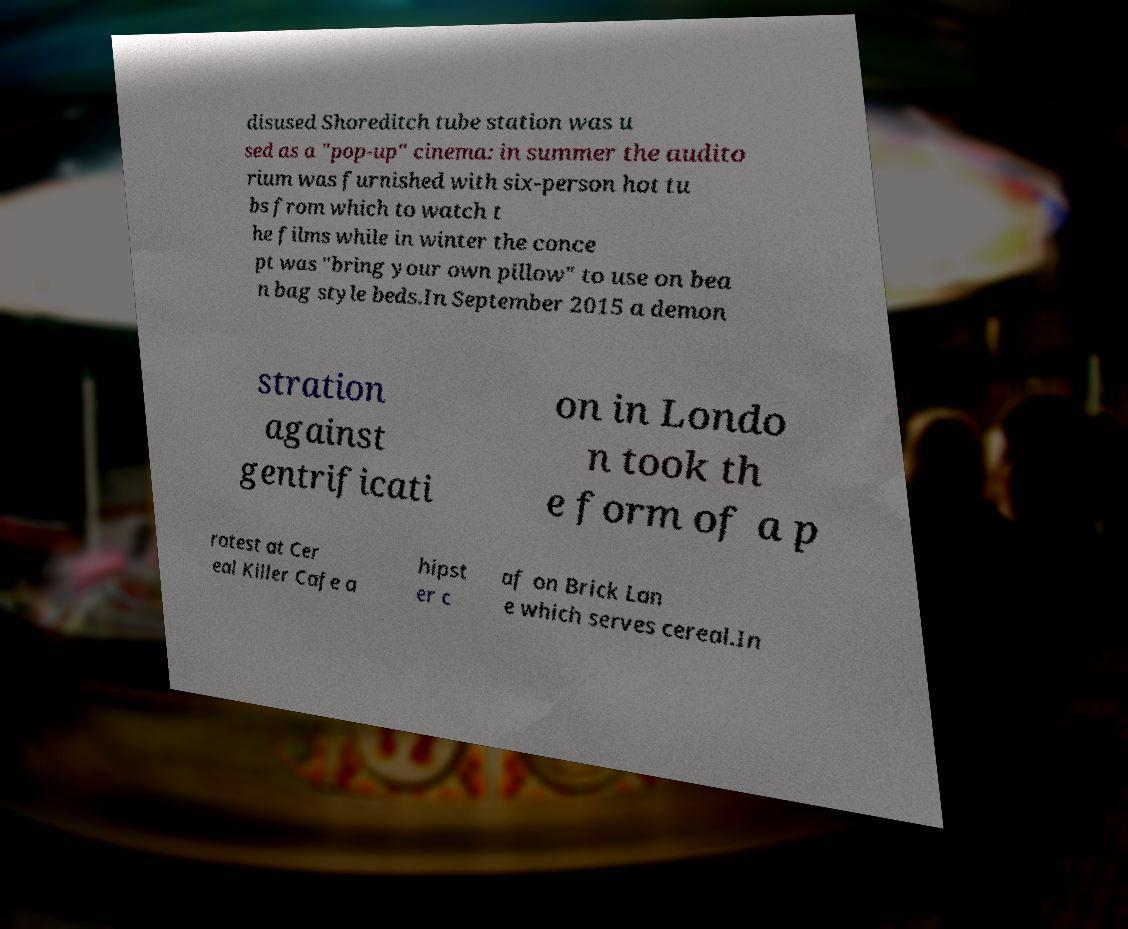Please identify and transcribe the text found in this image. disused Shoreditch tube station was u sed as a "pop-up" cinema: in summer the audito rium was furnished with six-person hot tu bs from which to watch t he films while in winter the conce pt was "bring your own pillow" to use on bea n bag style beds.In September 2015 a demon stration against gentrificati on in Londo n took th e form of a p rotest at Cer eal Killer Cafe a hipst er c af on Brick Lan e which serves cereal.In 